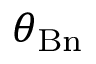Convert formula to latex. <formula><loc_0><loc_0><loc_500><loc_500>\theta _ { B n }</formula> 